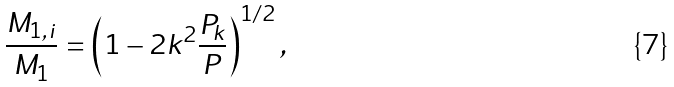Convert formula to latex. <formula><loc_0><loc_0><loc_500><loc_500>\frac { M _ { 1 , i } } { M _ { 1 } } = \left ( 1 - 2 k ^ { 2 } \frac { P _ { k } } { P } \right ) ^ { 1 / 2 } ,</formula> 